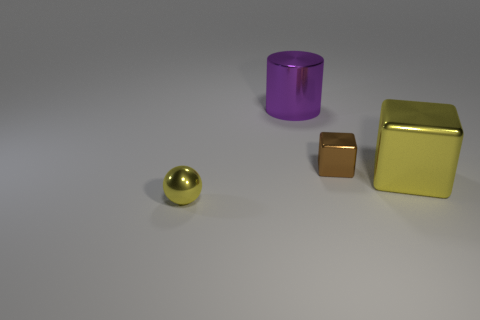Add 4 large yellow cubes. How many objects exist? 8 Subtract all cylinders. How many objects are left? 3 Subtract 0 red spheres. How many objects are left? 4 Subtract all small brown metal cylinders. Subtract all tiny brown things. How many objects are left? 3 Add 3 shiny blocks. How many shiny blocks are left? 5 Add 3 small blocks. How many small blocks exist? 4 